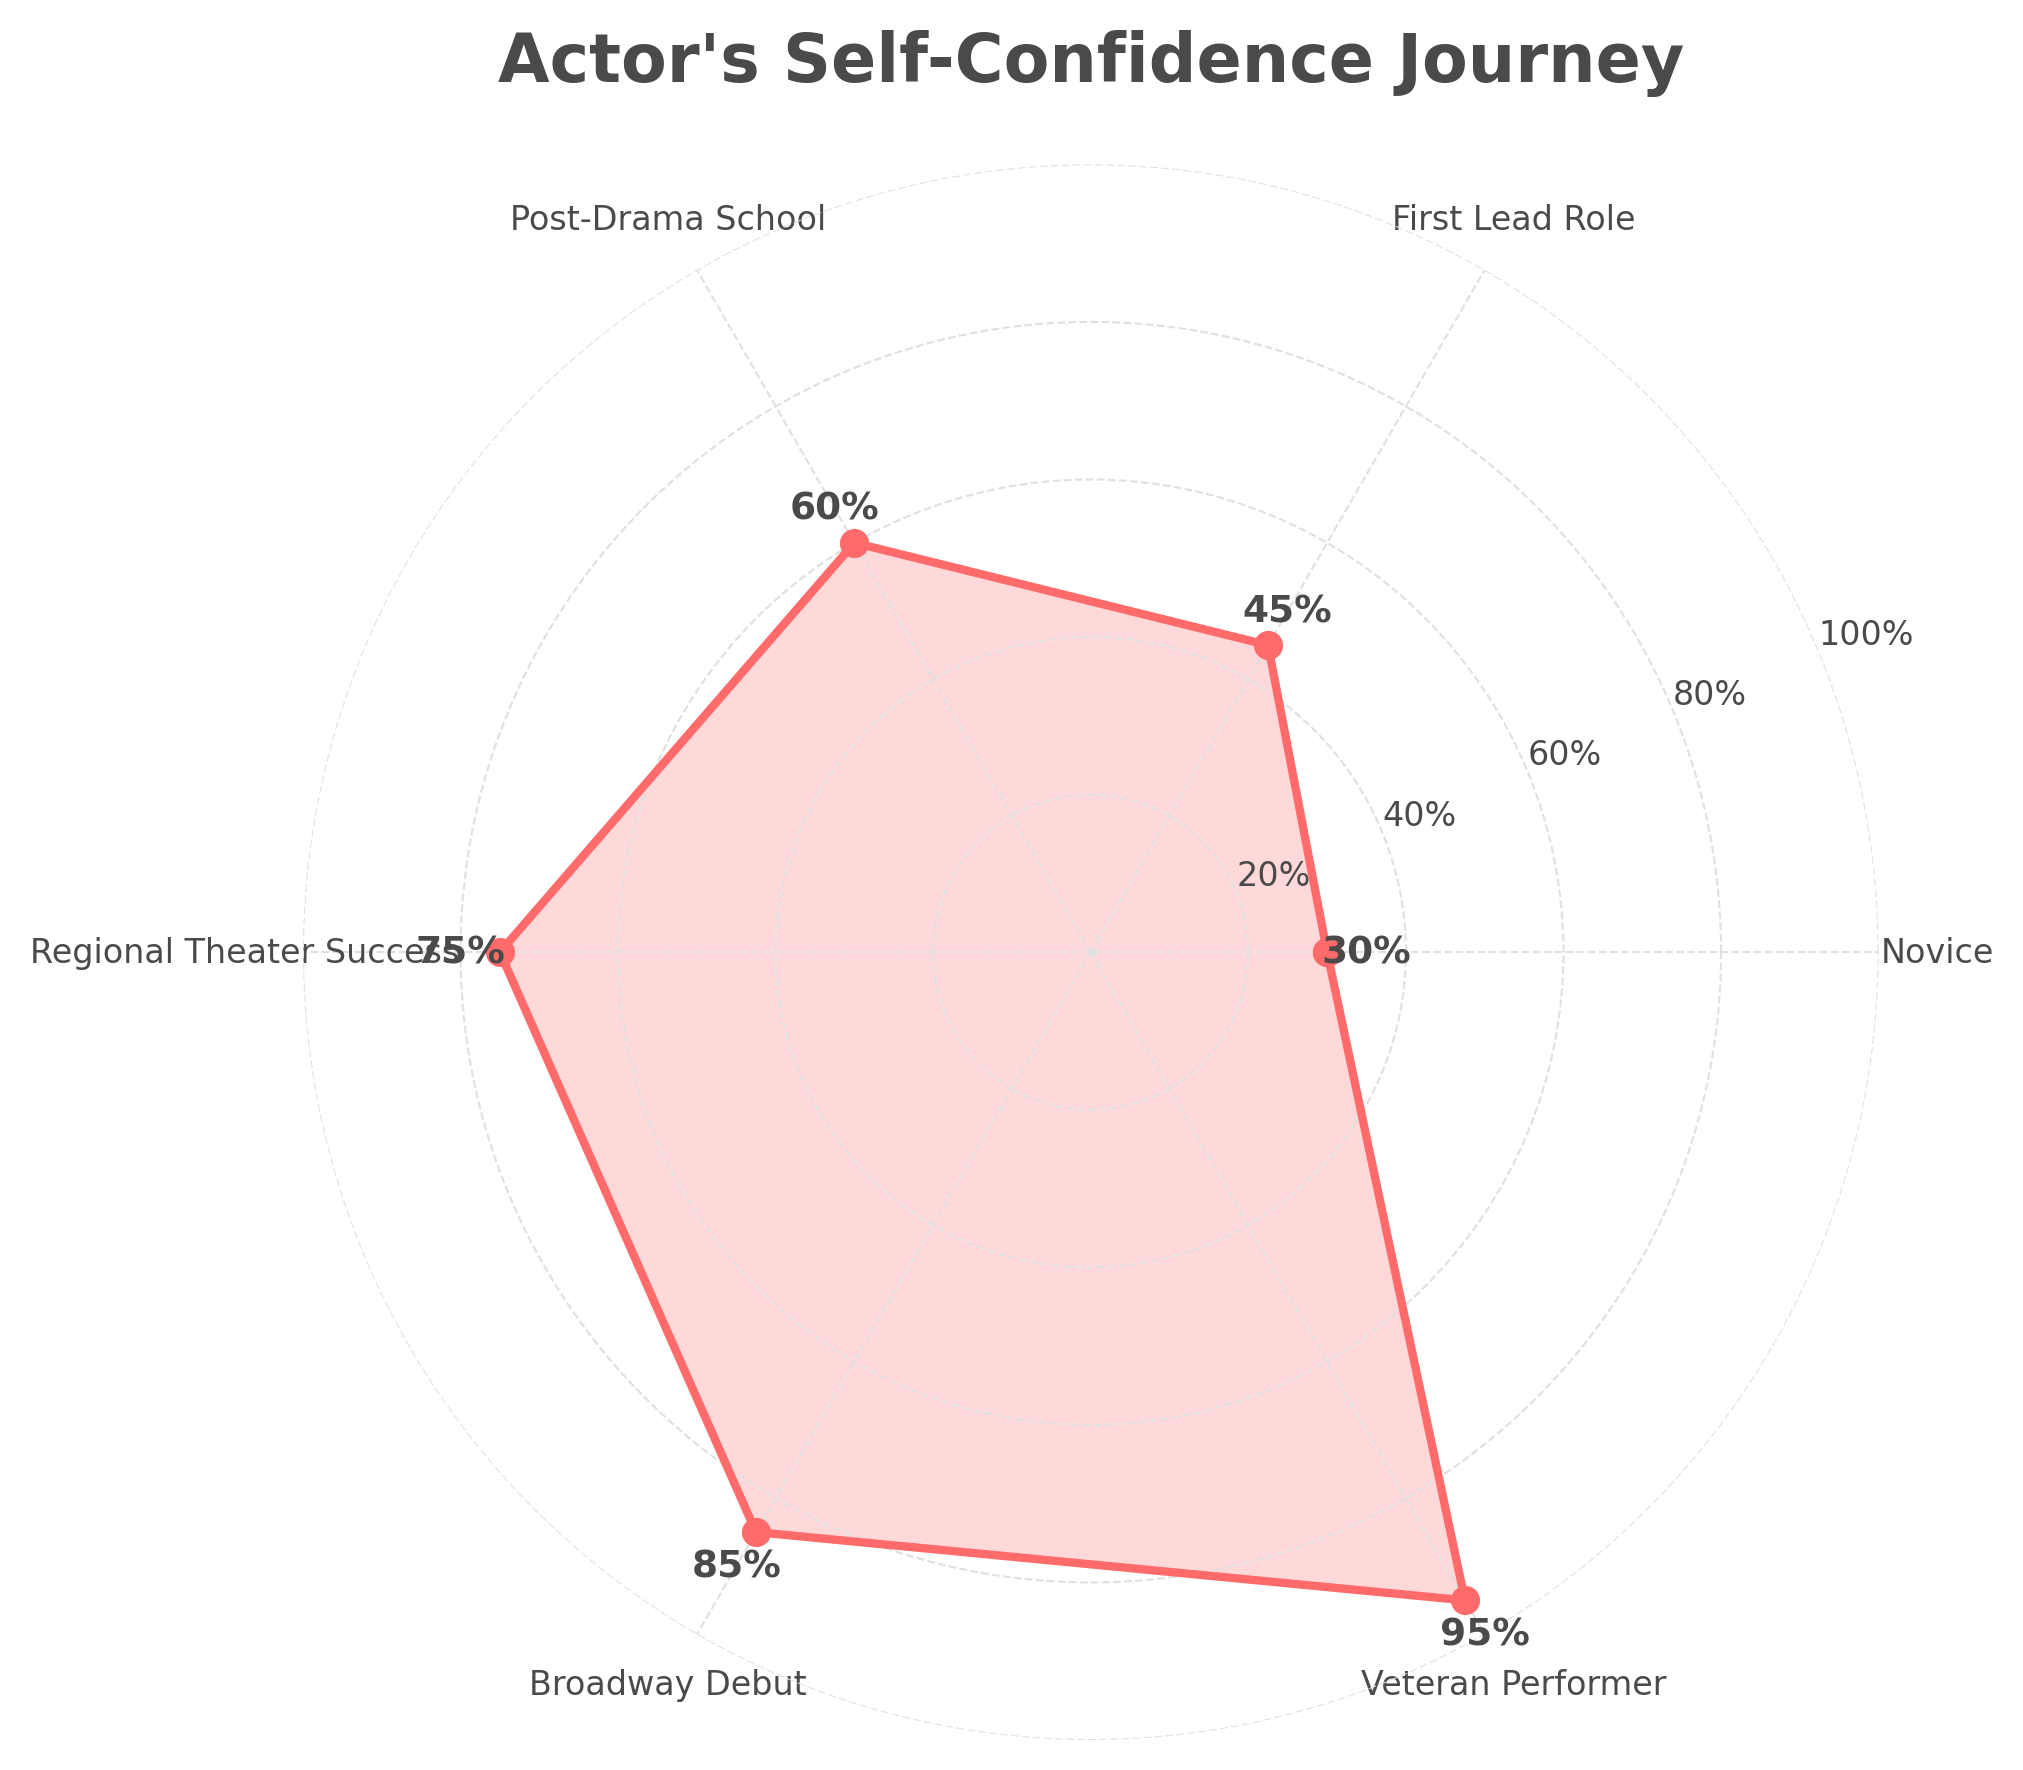What is the title of the chart? The title is displayed at the top of the chart. It reads "Actor's Self-Confidence Journey".
Answer: Actor's Self-Confidence Journey How many stages are shown in the actor's career journey? By counting the categories around the chart, we see there are six: Novice, First Lead Role, Post-Drama School, Regional Theater Success, Broadway Debut, Veteran Performer.
Answer: Six Which stage shows the highest level of self-confidence? The labels and percentages at the edge of the chart indicate that the highest value is at the Veteran Performer stage with 95%.
Answer: Veteran Performer What is the self-confidence level at the Broadway Debut stage? The chart shows the self-confidence percentages for each stage. For the Broadway Debut stage, the label indicates 85%.
Answer: 85% How does the self-confidence level change from the Novice stage to the First Lead Role stage? Observing the values, the self-confidence level changes from 30% at the Novice stage to 45% at the First Lead Role stage, which is an increase of 15%.
Answer: Increases by 15% What is the average self-confidence level across all the stages in the chart? To find the average, sum the self-confidence levels (30 + 45 + 60 + 75 + 85 + 95) and divide by the number of stages (6). The calculation is 390/6 = 65.
Answer: 65 Which stages show a self-confidence level below 50%? The chart indicates two stages below 50%: Novice (30%) and First Lead Role (45%).
Answer: Novice, First Lead Role How much does the self-confidence level increase from Regional Theater Success to Veteran Performer? By examining the values, the increase is from 75% at Regional Theater Success to 95% at Veteran Performer, which is an increase of 20%.
Answer: Increases by 20% What is the difference in self-confidence levels between Post-Drama School and Broadway Debut? The Post-Drama School stage shows 60% and the Broadway Debut stage shows 85%, resulting in a 25% difference (85% - 60%).
Answer: 25% Which stage has the least self-confidence in the chart? The chart shows that the Novice stage has the lowest value at 30%.
Answer: Novice 